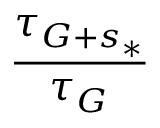<formula> <loc_0><loc_0><loc_500><loc_500>\frac { \tau _ { G + s _ { * } } } { \tau _ { G } }</formula> 